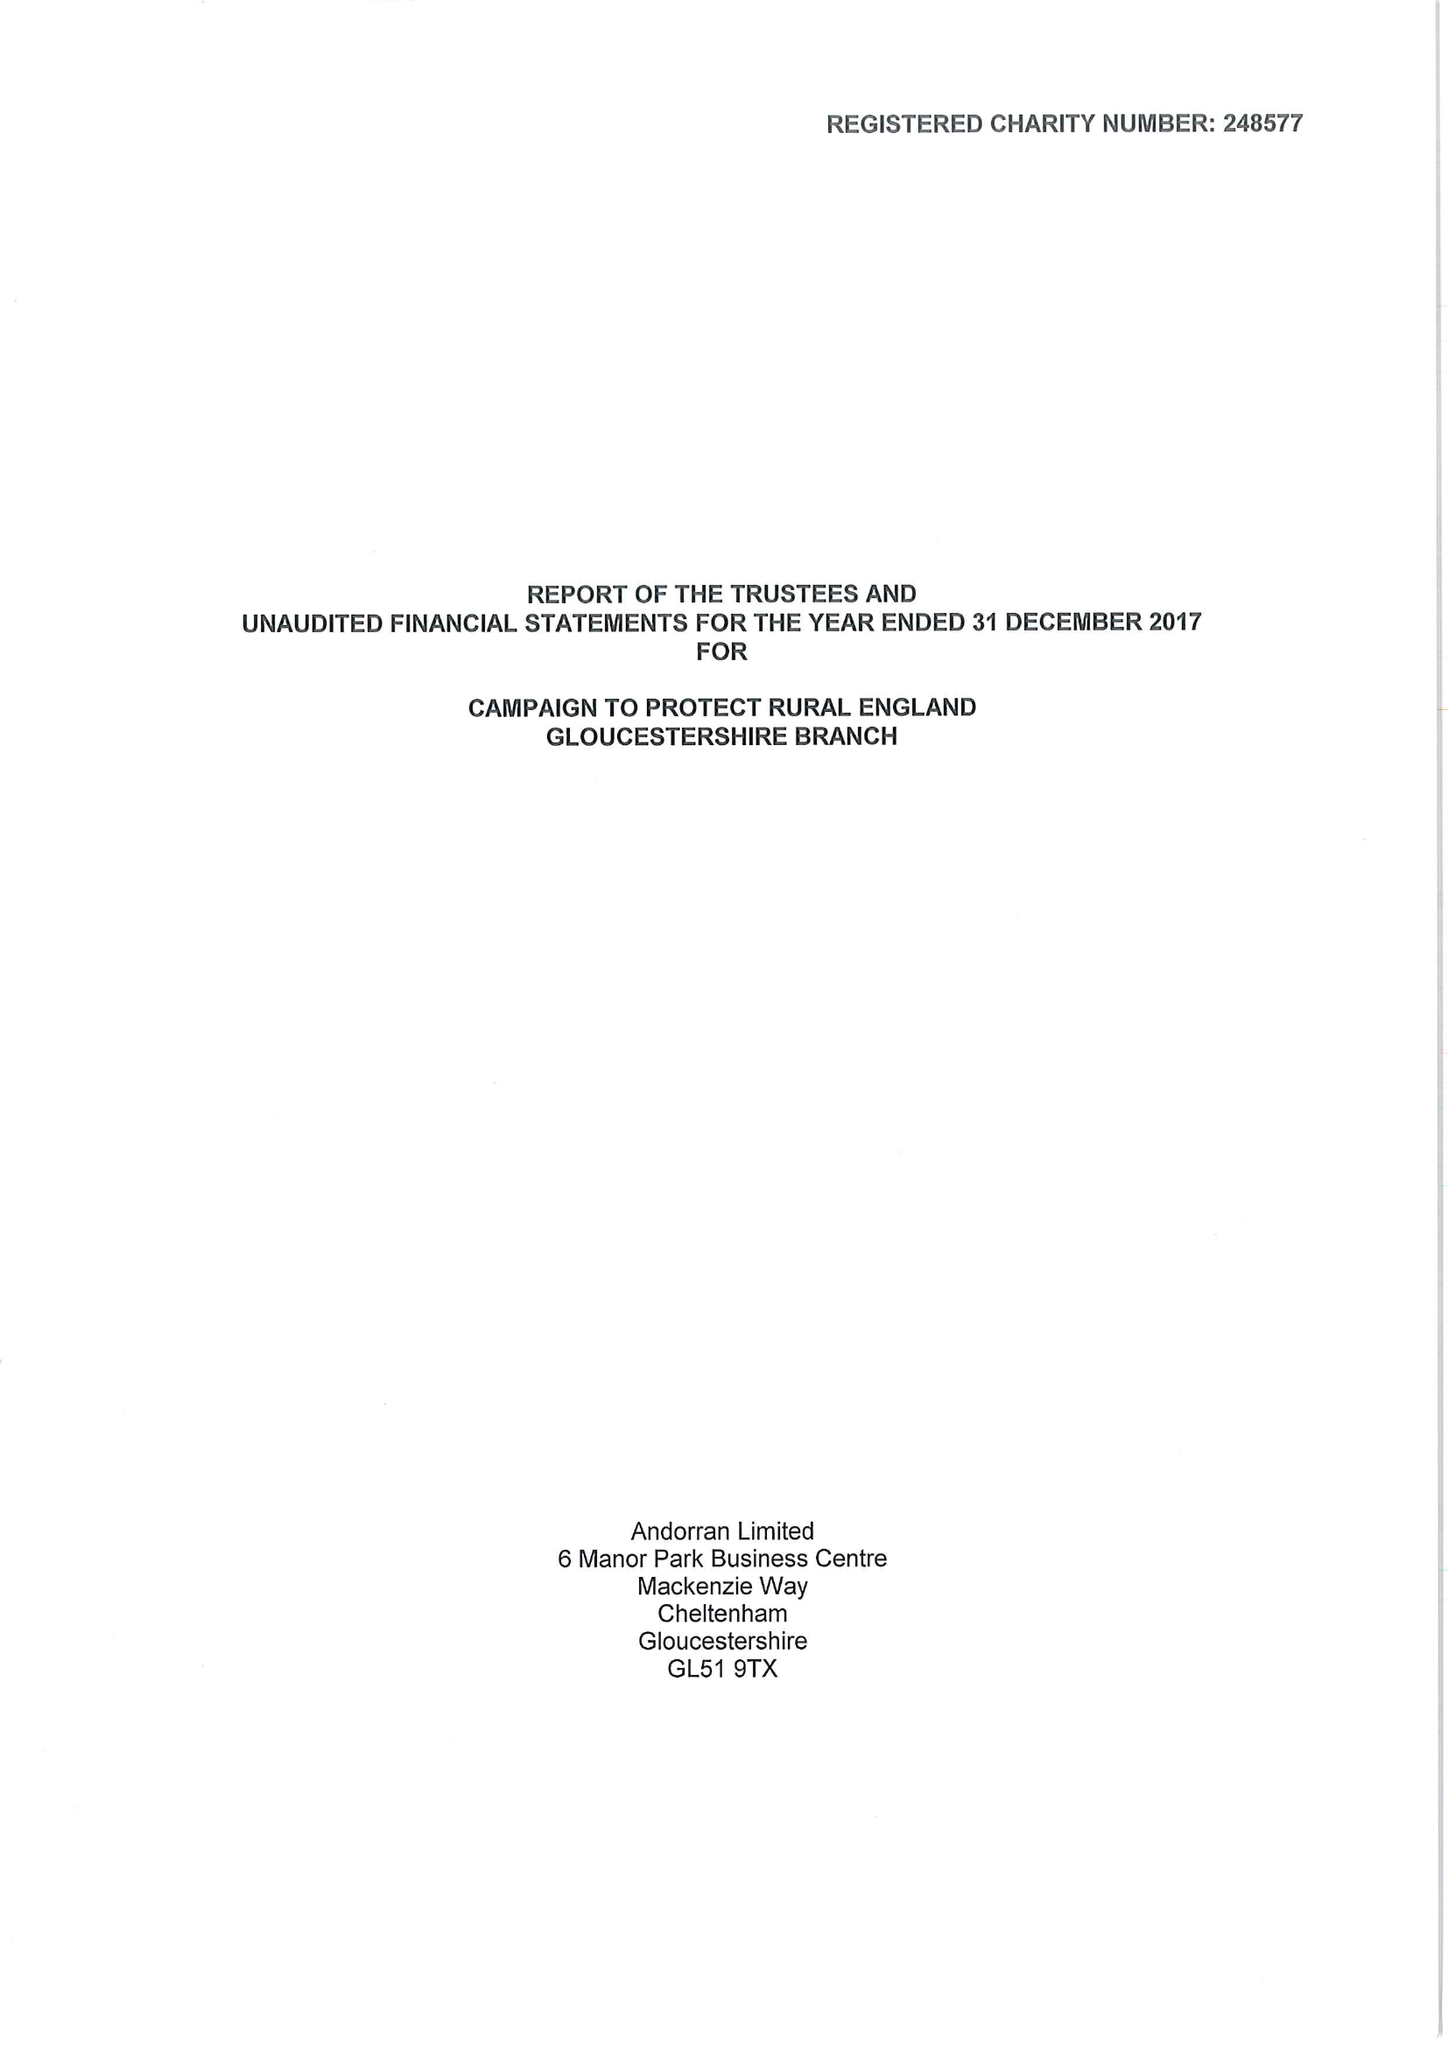What is the value for the address__street_line?
Answer the question using a single word or phrase. 15 COLLEGE GREEN 